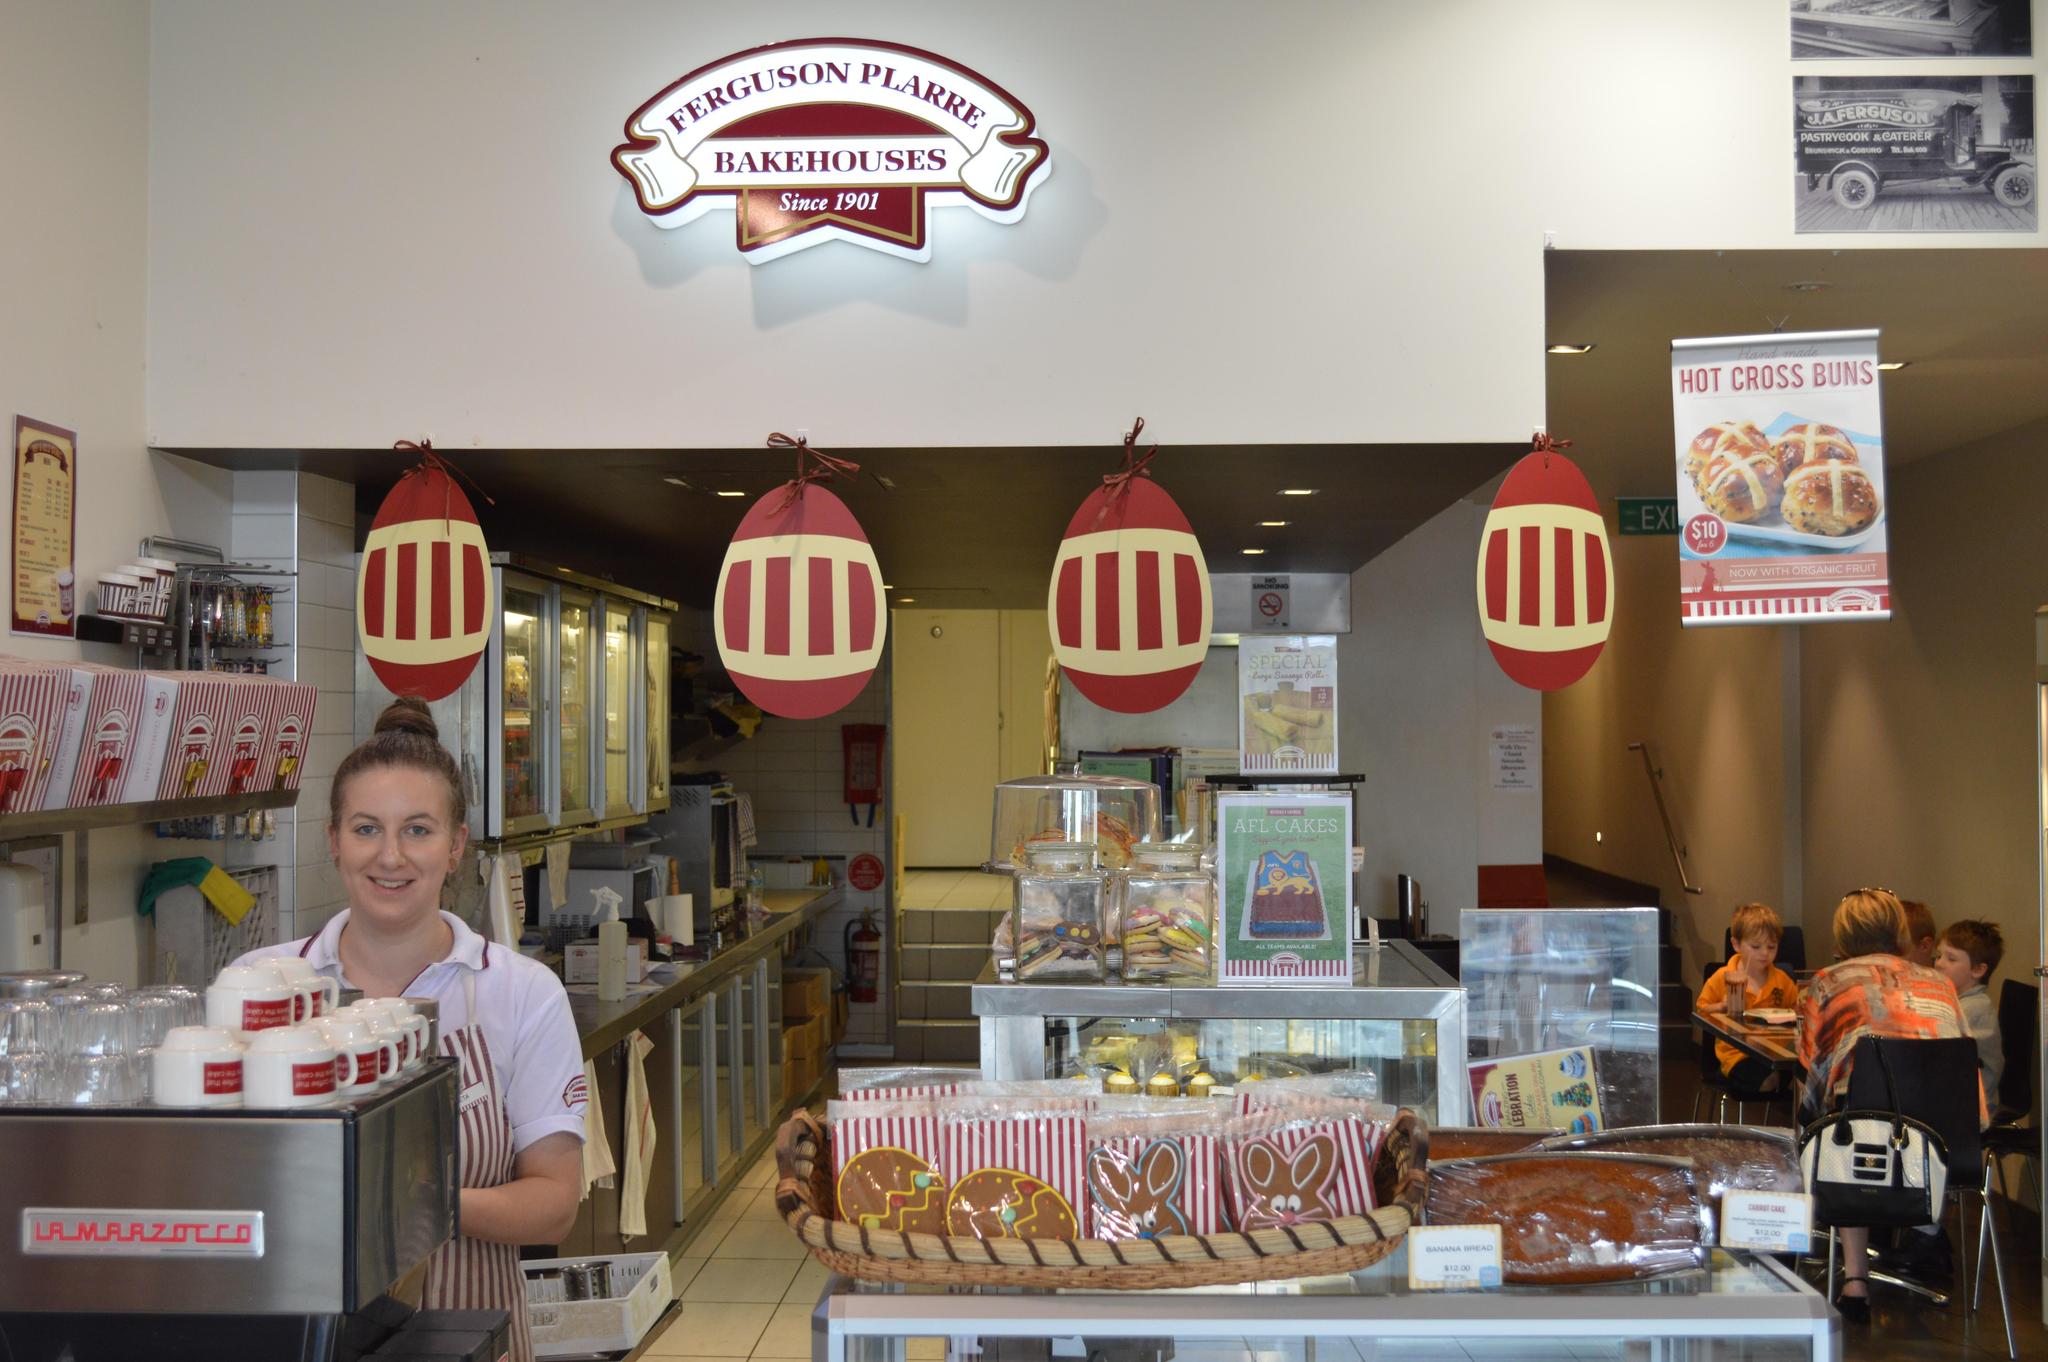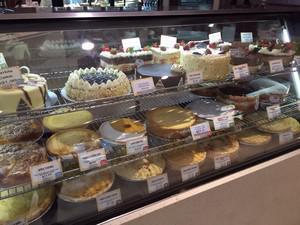The first image is the image on the left, the second image is the image on the right. For the images displayed, is the sentence "There is a female wearing her hair in a high bun next to some pastries." factually correct? Answer yes or no. Yes. The first image is the image on the left, the second image is the image on the right. For the images displayed, is the sentence "A woman in white with her hair in a bun stands behind a counter in one image." factually correct? Answer yes or no. Yes. 